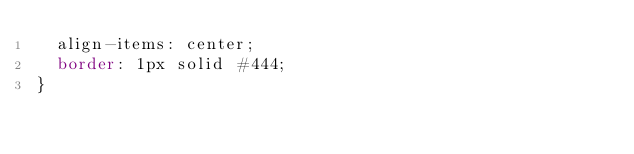Convert code to text. <code><loc_0><loc_0><loc_500><loc_500><_CSS_>  align-items: center;
  border: 1px solid #444;
}
</code> 